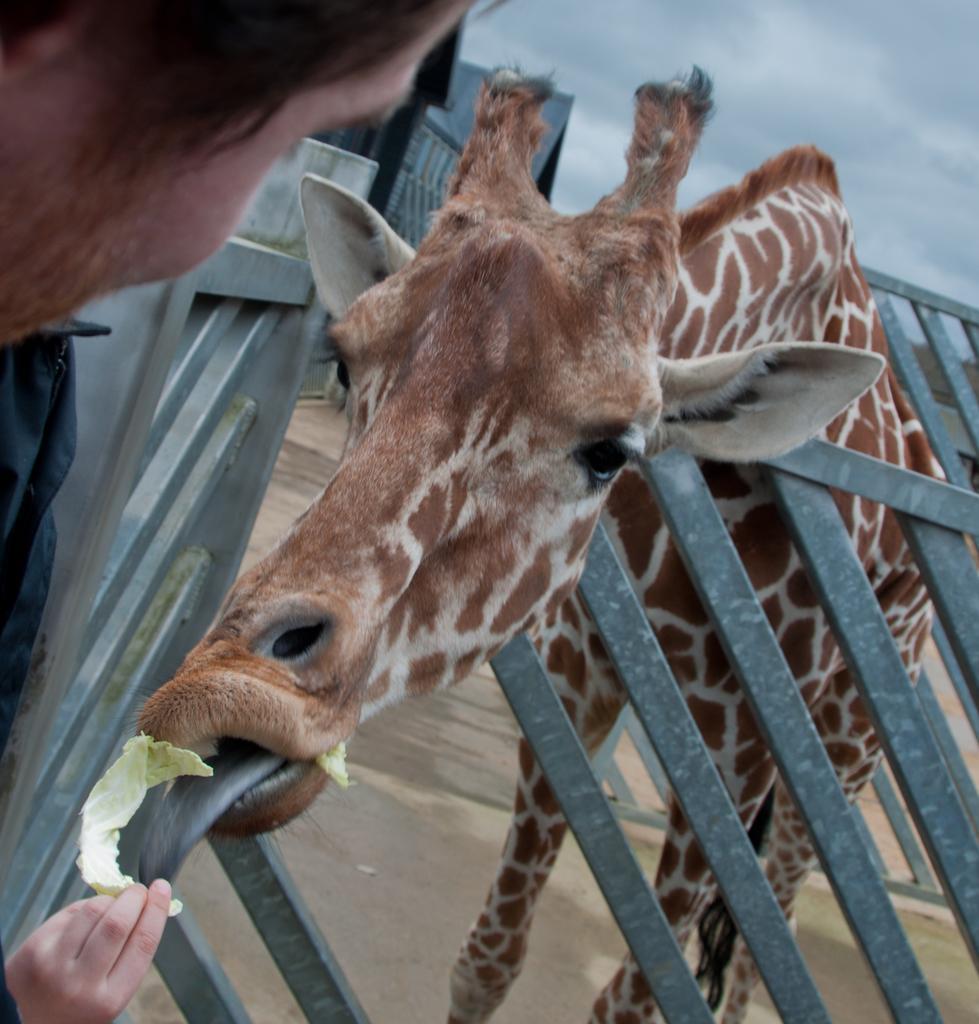Please provide a concise description of this image. In this picture there is a giraffe standing behind the railing and eating. There is a person holding the food. At the top there are clouds. At the back there is a building. 